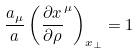<formula> <loc_0><loc_0><loc_500><loc_500>\frac { a _ { \mu } } { a } \left ( \frac { \partial x } { \partial \rho } ^ { \mu } \right ) _ { x _ { \bot } } = 1</formula> 